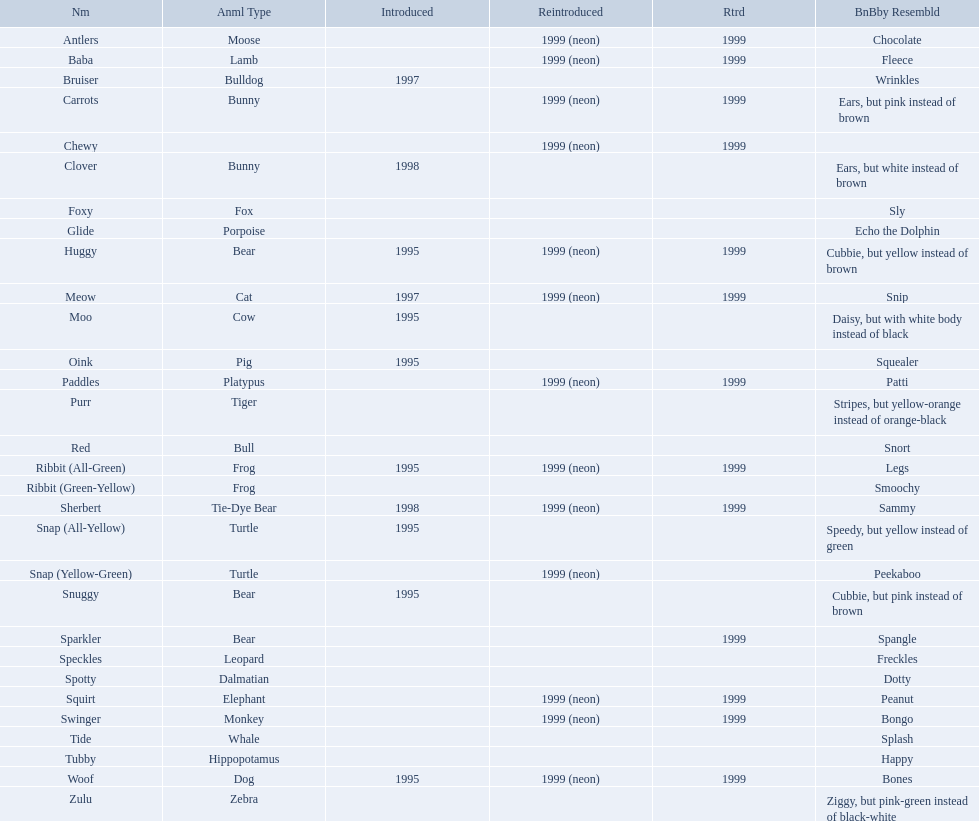What are the types of pillow pal animals? Antlers, Moose, Lamb, Bulldog, Bunny, , Bunny, Fox, Porpoise, Bear, Cat, Cow, Pig, Platypus, Tiger, Bull, Frog, Frog, Tie-Dye Bear, Turtle, Turtle, Bear, Bear, Leopard, Dalmatian, Elephant, Monkey, Whale, Hippopotamus, Dog, Zebra. Of those, which is a dalmatian? Dalmatian. What is the name of the dalmatian? Spotty. What are all the pillow pals? Antlers, Baba, Bruiser, Carrots, Chewy, Clover, Foxy, Glide, Huggy, Meow, Moo, Oink, Paddles, Purr, Red, Ribbit (All-Green), Ribbit (Green-Yellow), Sherbert, Snap (All-Yellow), Snap (Yellow-Green), Snuggy, Sparkler, Speckles, Spotty, Squirt, Swinger, Tide, Tubby, Woof, Zulu. Parse the full table in json format. {'header': ['Nm', 'Anml Type', 'Introduced', 'Reintroduced', 'Rtrd', 'BnBby Resembld'], 'rows': [['Antlers', 'Moose', '', '1999 (neon)', '1999', 'Chocolate'], ['Baba', 'Lamb', '', '1999 (neon)', '1999', 'Fleece'], ['Bruiser', 'Bulldog', '1997', '', '', 'Wrinkles'], ['Carrots', 'Bunny', '', '1999 (neon)', '1999', 'Ears, but pink instead of brown'], ['Chewy', '', '', '1999 (neon)', '1999', ''], ['Clover', 'Bunny', '1998', '', '', 'Ears, but white instead of brown'], ['Foxy', 'Fox', '', '', '', 'Sly'], ['Glide', 'Porpoise', '', '', '', 'Echo the Dolphin'], ['Huggy', 'Bear', '1995', '1999 (neon)', '1999', 'Cubbie, but yellow instead of brown'], ['Meow', 'Cat', '1997', '1999 (neon)', '1999', 'Snip'], ['Moo', 'Cow', '1995', '', '', 'Daisy, but with white body instead of black'], ['Oink', 'Pig', '1995', '', '', 'Squealer'], ['Paddles', 'Platypus', '', '1999 (neon)', '1999', 'Patti'], ['Purr', 'Tiger', '', '', '', 'Stripes, but yellow-orange instead of orange-black'], ['Red', 'Bull', '', '', '', 'Snort'], ['Ribbit (All-Green)', 'Frog', '1995', '1999 (neon)', '1999', 'Legs'], ['Ribbit (Green-Yellow)', 'Frog', '', '', '', 'Smoochy'], ['Sherbert', 'Tie-Dye Bear', '1998', '1999 (neon)', '1999', 'Sammy'], ['Snap (All-Yellow)', 'Turtle', '1995', '', '', 'Speedy, but yellow instead of green'], ['Snap (Yellow-Green)', 'Turtle', '', '1999 (neon)', '', 'Peekaboo'], ['Snuggy', 'Bear', '1995', '', '', 'Cubbie, but pink instead of brown'], ['Sparkler', 'Bear', '', '', '1999', 'Spangle'], ['Speckles', 'Leopard', '', '', '', 'Freckles'], ['Spotty', 'Dalmatian', '', '', '', 'Dotty'], ['Squirt', 'Elephant', '', '1999 (neon)', '1999', 'Peanut'], ['Swinger', 'Monkey', '', '1999 (neon)', '1999', 'Bongo'], ['Tide', 'Whale', '', '', '', 'Splash'], ['Tubby', 'Hippopotamus', '', '', '', 'Happy'], ['Woof', 'Dog', '1995', '1999 (neon)', '1999', 'Bones'], ['Zulu', 'Zebra', '', '', '', 'Ziggy, but pink-green instead of black-white']]} Which is the only without a listed animal type? Chewy. 